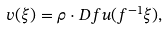Convert formula to latex. <formula><loc_0><loc_0><loc_500><loc_500>v ( \xi ) = \rho \cdot D f u ( f ^ { - 1 } \xi ) ,</formula> 